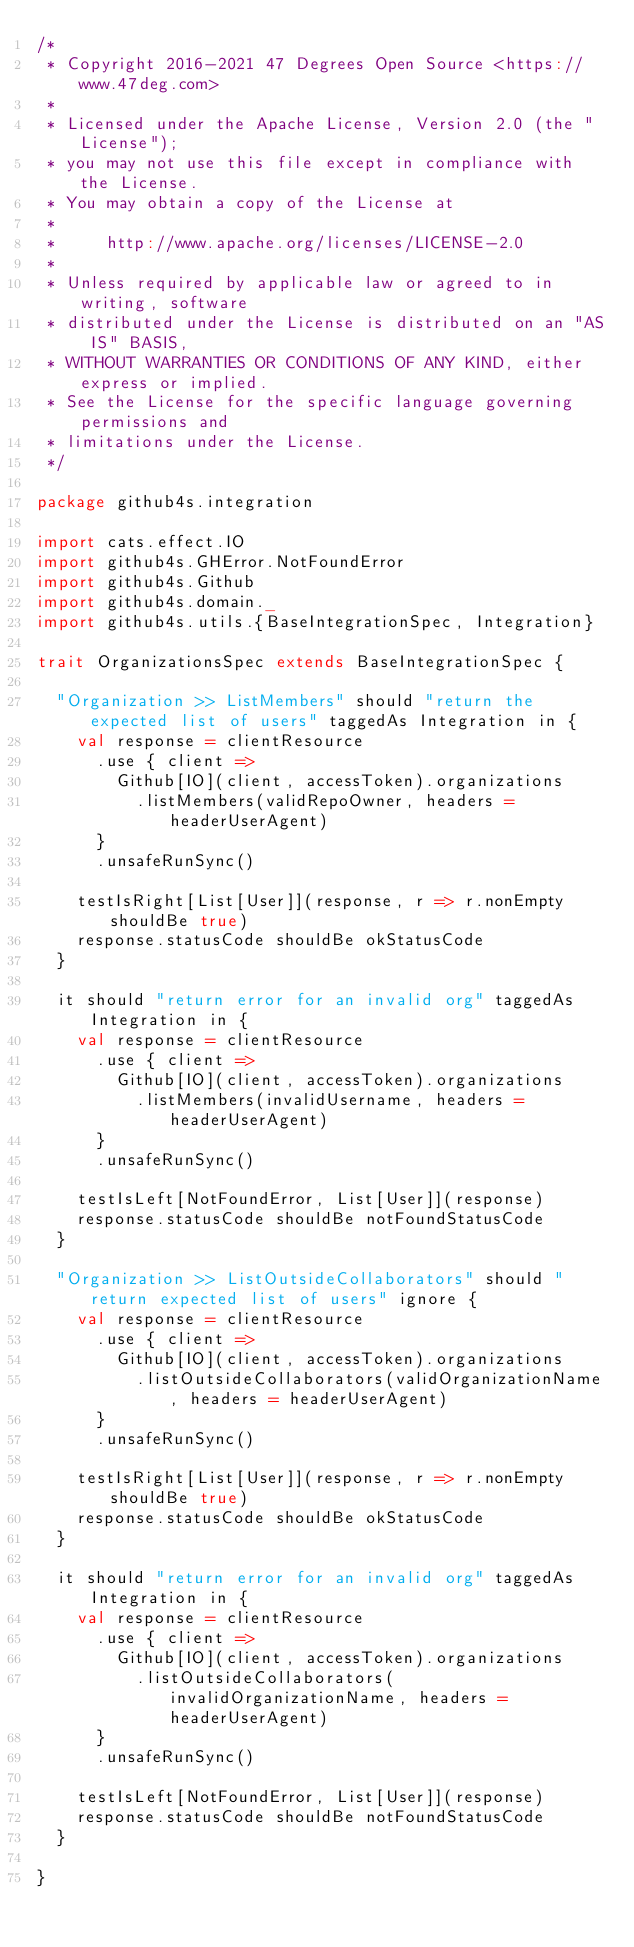<code> <loc_0><loc_0><loc_500><loc_500><_Scala_>/*
 * Copyright 2016-2021 47 Degrees Open Source <https://www.47deg.com>
 *
 * Licensed under the Apache License, Version 2.0 (the "License");
 * you may not use this file except in compliance with the License.
 * You may obtain a copy of the License at
 *
 *     http://www.apache.org/licenses/LICENSE-2.0
 *
 * Unless required by applicable law or agreed to in writing, software
 * distributed under the License is distributed on an "AS IS" BASIS,
 * WITHOUT WARRANTIES OR CONDITIONS OF ANY KIND, either express or implied.
 * See the License for the specific language governing permissions and
 * limitations under the License.
 */

package github4s.integration

import cats.effect.IO
import github4s.GHError.NotFoundError
import github4s.Github
import github4s.domain._
import github4s.utils.{BaseIntegrationSpec, Integration}

trait OrganizationsSpec extends BaseIntegrationSpec {

  "Organization >> ListMembers" should "return the expected list of users" taggedAs Integration in {
    val response = clientResource
      .use { client =>
        Github[IO](client, accessToken).organizations
          .listMembers(validRepoOwner, headers = headerUserAgent)
      }
      .unsafeRunSync()

    testIsRight[List[User]](response, r => r.nonEmpty shouldBe true)
    response.statusCode shouldBe okStatusCode
  }

  it should "return error for an invalid org" taggedAs Integration in {
    val response = clientResource
      .use { client =>
        Github[IO](client, accessToken).organizations
          .listMembers(invalidUsername, headers = headerUserAgent)
      }
      .unsafeRunSync()

    testIsLeft[NotFoundError, List[User]](response)
    response.statusCode shouldBe notFoundStatusCode
  }

  "Organization >> ListOutsideCollaborators" should "return expected list of users" ignore {
    val response = clientResource
      .use { client =>
        Github[IO](client, accessToken).organizations
          .listOutsideCollaborators(validOrganizationName, headers = headerUserAgent)
      }
      .unsafeRunSync()

    testIsRight[List[User]](response, r => r.nonEmpty shouldBe true)
    response.statusCode shouldBe okStatusCode
  }

  it should "return error for an invalid org" taggedAs Integration in {
    val response = clientResource
      .use { client =>
        Github[IO](client, accessToken).organizations
          .listOutsideCollaborators(invalidOrganizationName, headers = headerUserAgent)
      }
      .unsafeRunSync()

    testIsLeft[NotFoundError, List[User]](response)
    response.statusCode shouldBe notFoundStatusCode
  }

}
</code> 